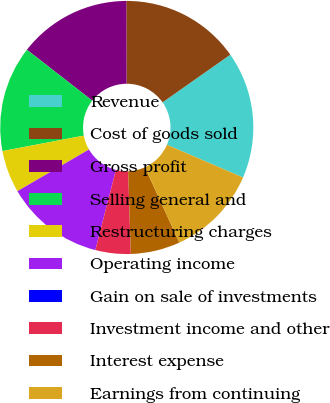<chart> <loc_0><loc_0><loc_500><loc_500><pie_chart><fcel>Revenue<fcel>Cost of goods sold<fcel>Gross profit<fcel>Selling general and<fcel>Restructuring charges<fcel>Operating income<fcel>Gain on sale of investments<fcel>Investment income and other<fcel>Interest expense<fcel>Earnings from continuing<nl><fcel>16.22%<fcel>15.31%<fcel>14.41%<fcel>13.51%<fcel>5.41%<fcel>12.61%<fcel>0.0%<fcel>4.5%<fcel>6.31%<fcel>11.71%<nl></chart> 